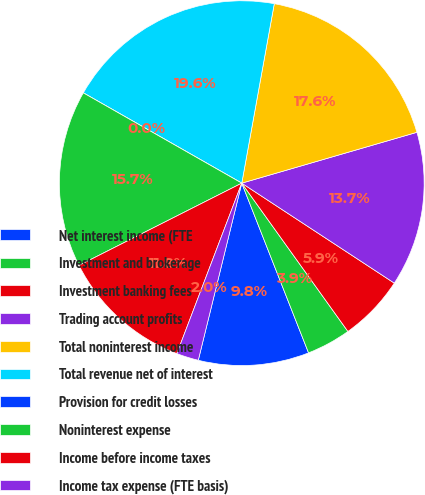Convert chart to OTSL. <chart><loc_0><loc_0><loc_500><loc_500><pie_chart><fcel>Net interest income (FTE<fcel>Investment and brokerage<fcel>Investment banking fees<fcel>Trading account profits<fcel>Total noninterest income<fcel>Total revenue net of interest<fcel>Provision for credit losses<fcel>Noninterest expense<fcel>Income before income taxes<fcel>Income tax expense (FTE basis)<nl><fcel>9.8%<fcel>3.92%<fcel>5.88%<fcel>13.73%<fcel>17.65%<fcel>19.61%<fcel>0.0%<fcel>15.69%<fcel>11.76%<fcel>1.96%<nl></chart> 